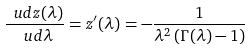Convert formula to latex. <formula><loc_0><loc_0><loc_500><loc_500>\frac { \ u d z ( \lambda ) } { \ u d \lambda } = z ^ { \prime } ( \lambda ) = - \frac { 1 } { \lambda ^ { 2 } \left ( \Gamma ( \lambda ) - 1 \right ) }</formula> 